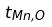Convert formula to latex. <formula><loc_0><loc_0><loc_500><loc_500>t _ { M n , O }</formula> 